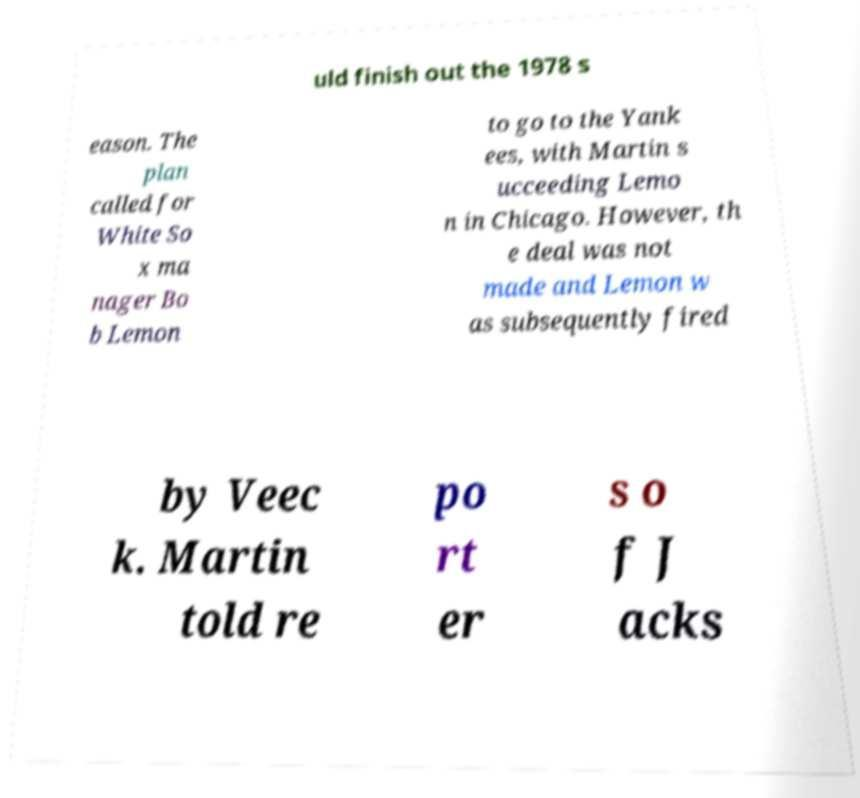Could you assist in decoding the text presented in this image and type it out clearly? uld finish out the 1978 s eason. The plan called for White So x ma nager Bo b Lemon to go to the Yank ees, with Martin s ucceeding Lemo n in Chicago. However, th e deal was not made and Lemon w as subsequently fired by Veec k. Martin told re po rt er s o f J acks 